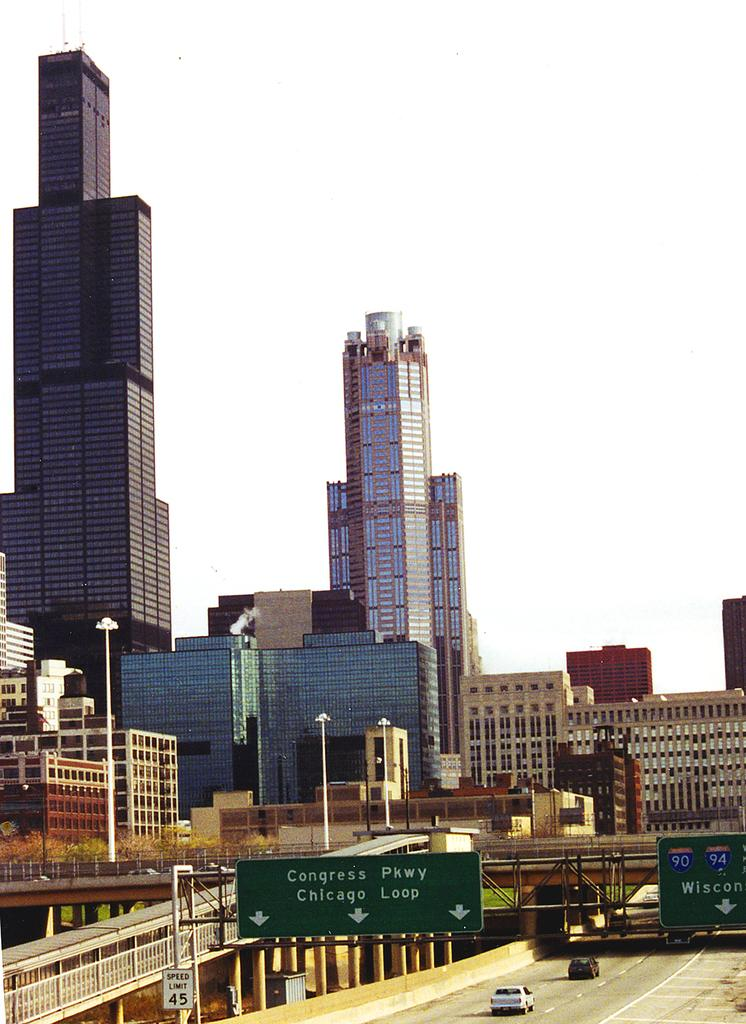What type of structures are present in the image? There are tower buildings and other buildings in the image. What can be seen on the roads in the image? There are vehicles on the road in the image. Are there any architectural features that stand out in the image? Yes, there are bridges in the image. What type of vegetable is being used as a lead weight in the image? There is no vegetable or lead weight present in the image. 